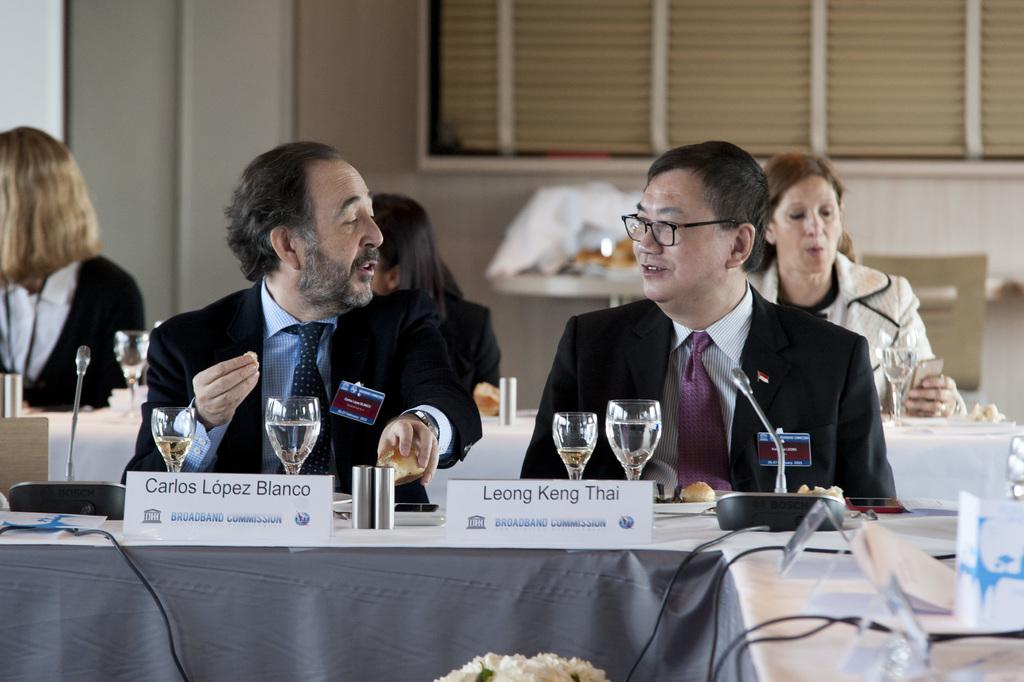<image>
Present a compact description of the photo's key features. Carlos and Leong sit ata long table with other people while having microphones and beverages in front of them. 